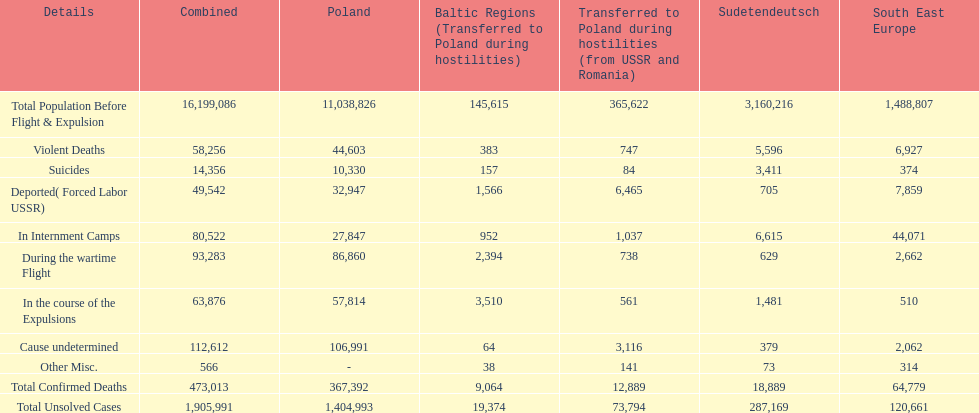How many total confirmed deaths were there in the baltic states? 9,064. How many deaths had an undetermined cause? 64. How many deaths in that region were miscellaneous? 38. Were there more deaths from an undetermined cause or that were listed as miscellaneous? Cause undetermined. 